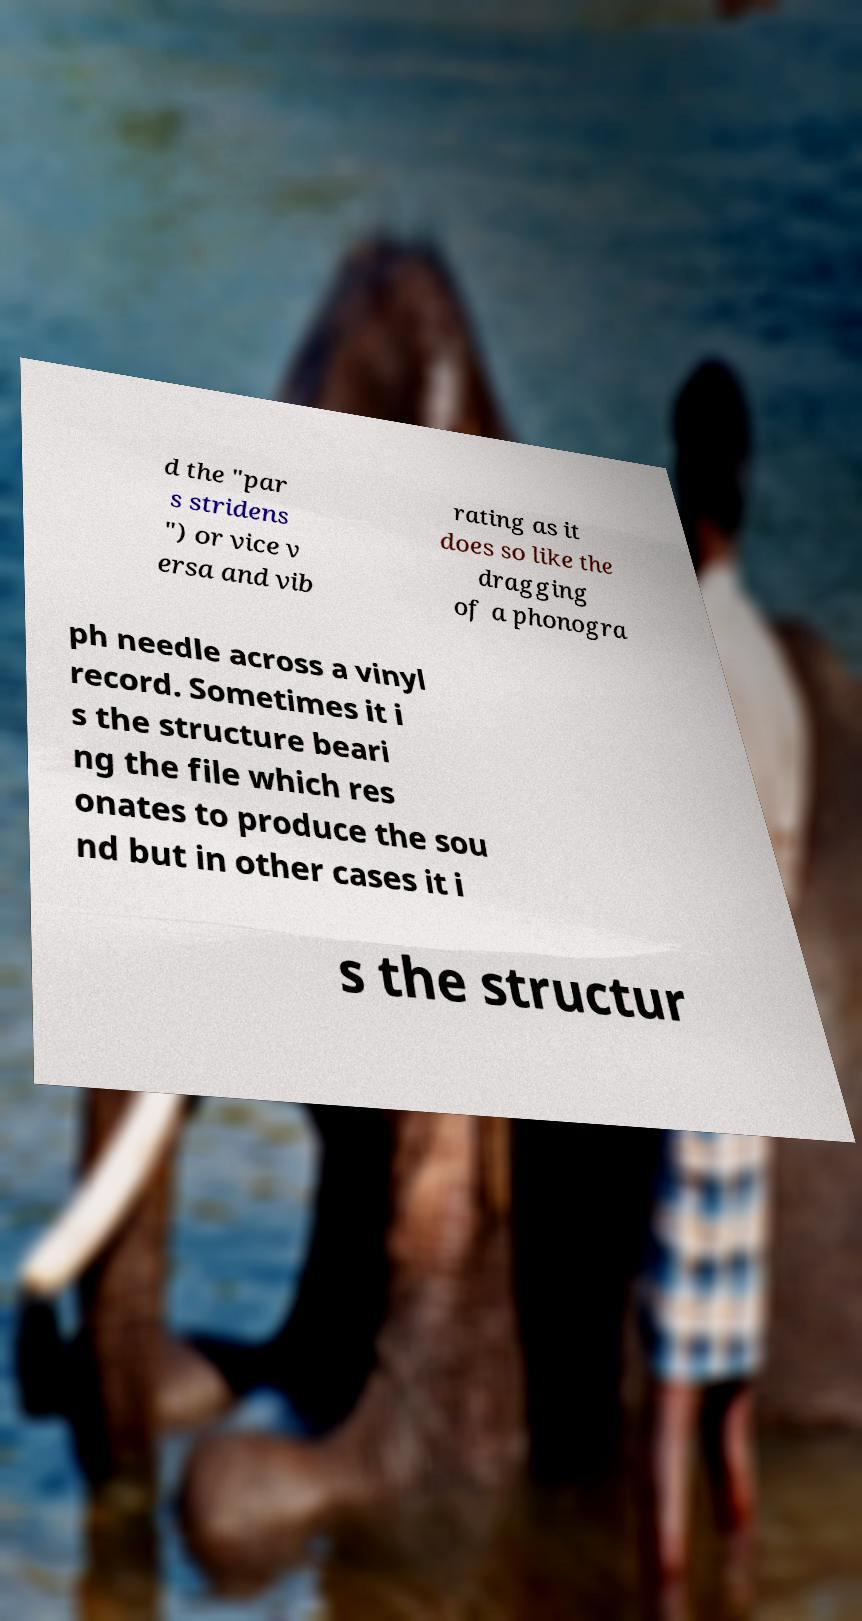Please identify and transcribe the text found in this image. d the "par s stridens ") or vice v ersa and vib rating as it does so like the dragging of a phonogra ph needle across a vinyl record. Sometimes it i s the structure beari ng the file which res onates to produce the sou nd but in other cases it i s the structur 